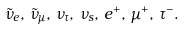Convert formula to latex. <formula><loc_0><loc_0><loc_500><loc_500>\tilde { \nu } _ { e } , \, \tilde { \nu } _ { \mu } , \, \nu _ { \tau } , \, \nu _ { s } , \, e ^ { + } , \, \mu ^ { + } , \, \tau ^ { - } .</formula> 